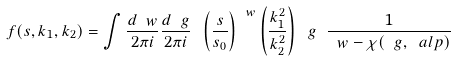<formula> <loc_0><loc_0><loc_500><loc_500>f ( s , k _ { 1 } , k _ { 2 } ) = \int \frac { d \ w } { 2 \pi i } \frac { d \ g } { 2 \pi i } \ \left ( \frac { s } { s _ { 0 } } \right ) ^ { \ w } \left ( \frac { k _ { 1 } ^ { 2 } } { k _ { 2 } ^ { 2 } } \right ) ^ { \ } g \ \frac { 1 } { \ w - \chi ( \ g , \ a l p ) }</formula> 